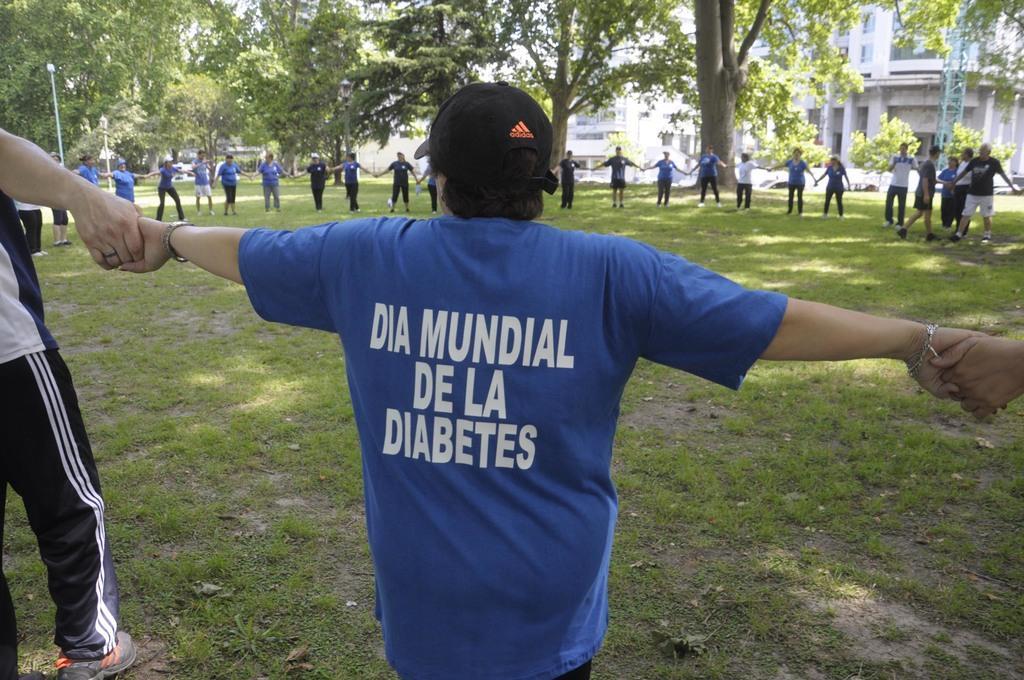Can you describe this image briefly? In the middle a man is standing, he wore blue color t-shirt. A group of people are holding their hands together, forming a chain. At the back side there are trees. On the right side there are houses in this image. 